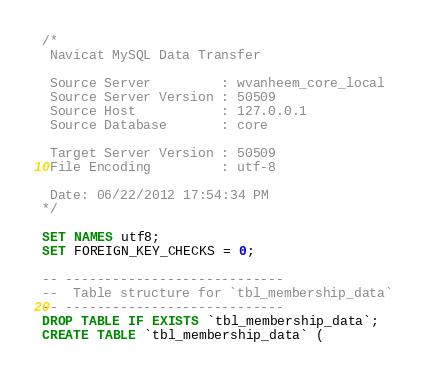<code> <loc_0><loc_0><loc_500><loc_500><_SQL_>/*
 Navicat MySQL Data Transfer

 Source Server         : wvanheem_core_local
 Source Server Version : 50509
 Source Host           : 127.0.0.1
 Source Database       : core

 Target Server Version : 50509
 File Encoding         : utf-8

 Date: 06/22/2012 17:54:34 PM
*/

SET NAMES utf8;
SET FOREIGN_KEY_CHECKS = 0;

-- ----------------------------
--  Table structure for `tbl_membership_data`
-- ----------------------------
DROP TABLE IF EXISTS `tbl_membership_data`;
CREATE TABLE `tbl_membership_data` (</code> 